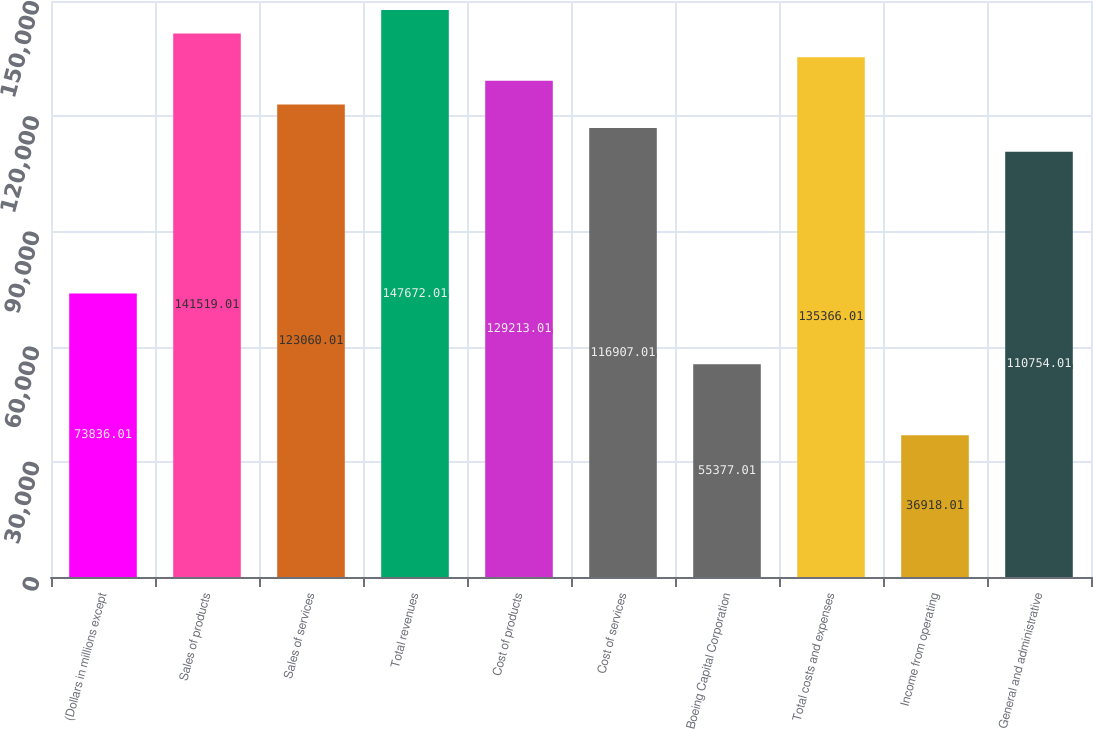<chart> <loc_0><loc_0><loc_500><loc_500><bar_chart><fcel>(Dollars in millions except<fcel>Sales of products<fcel>Sales of services<fcel>Total revenues<fcel>Cost of products<fcel>Cost of services<fcel>Boeing Capital Corporation<fcel>Total costs and expenses<fcel>Income from operating<fcel>General and administrative<nl><fcel>73836<fcel>141519<fcel>123060<fcel>147672<fcel>129213<fcel>116907<fcel>55377<fcel>135366<fcel>36918<fcel>110754<nl></chart> 